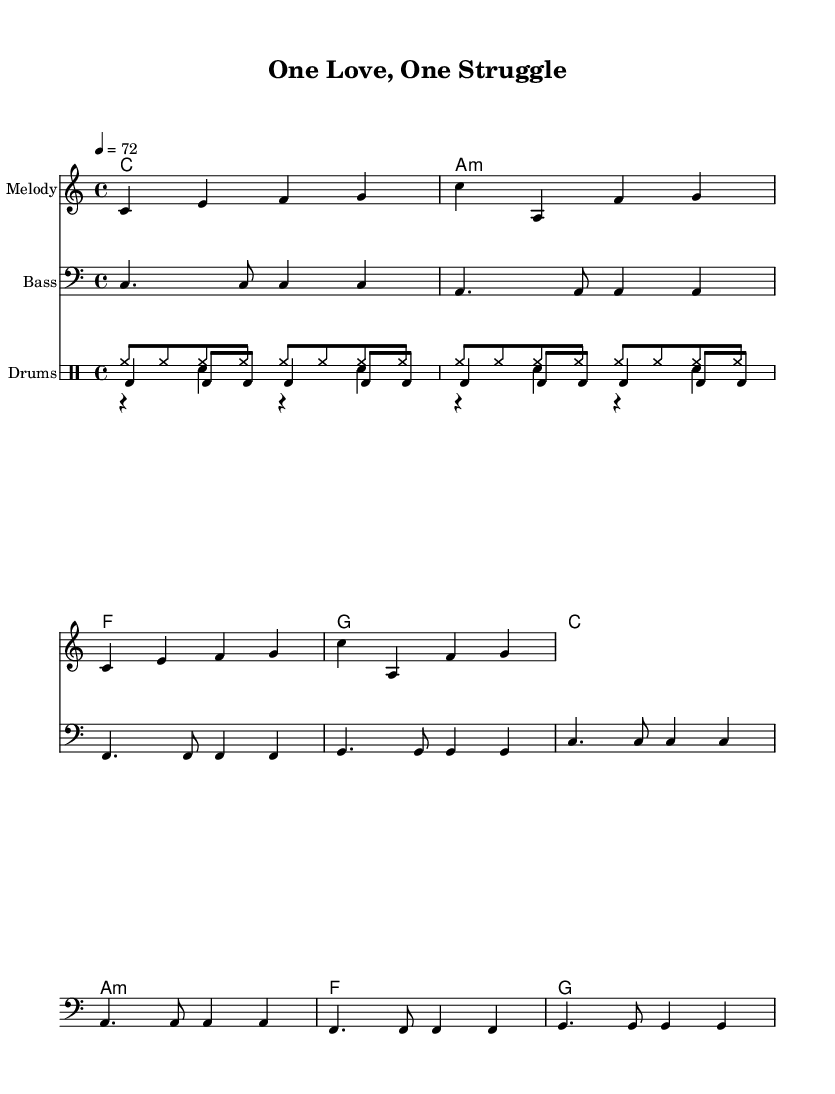What is the key signature of this music? The key signature is indicated at the beginning of the sheet music. It shows no sharps or flats, which corresponds to C major.
Answer: C major What is the time signature of this music? The time signature is located near the beginning of the score. It shows '4/4', indicating that there are four beats in each measure and a quarter note receives one beat.
Answer: 4/4 What is the tempo marking for this piece? The tempo marking can be found in the header section. It is listed as '4 = 72', meaning that a quarter note is to be played at a speed of 72 beats per minute.
Answer: 72 How many measures are in the melody? To determine the number of measures, count the groups of notes separated by vertical lines in the melody section. There are 8 measures in total presented.
Answer: 8 Which chord appears first in the harmony section? The first chord in the harmony section can be identified by looking at the chord symbols located above the melody notes. The first symbol is 'C'.
Answer: C What rhythm is used for the drums? The drum patterns can be observed in the drum section, with 'bd' representing bass drum, 'sn' for snare drum, and 'hh' for hi-hat. The pattern indicates a consistent rhythmic structure with alternating beats.
Answer: Alternating beats What is the main lyrical theme in this song? The lyrics indicate a unifying message that focuses on togetherness and a sense of peace, as represented in the line "One love, one heart."
Answer: Unity 